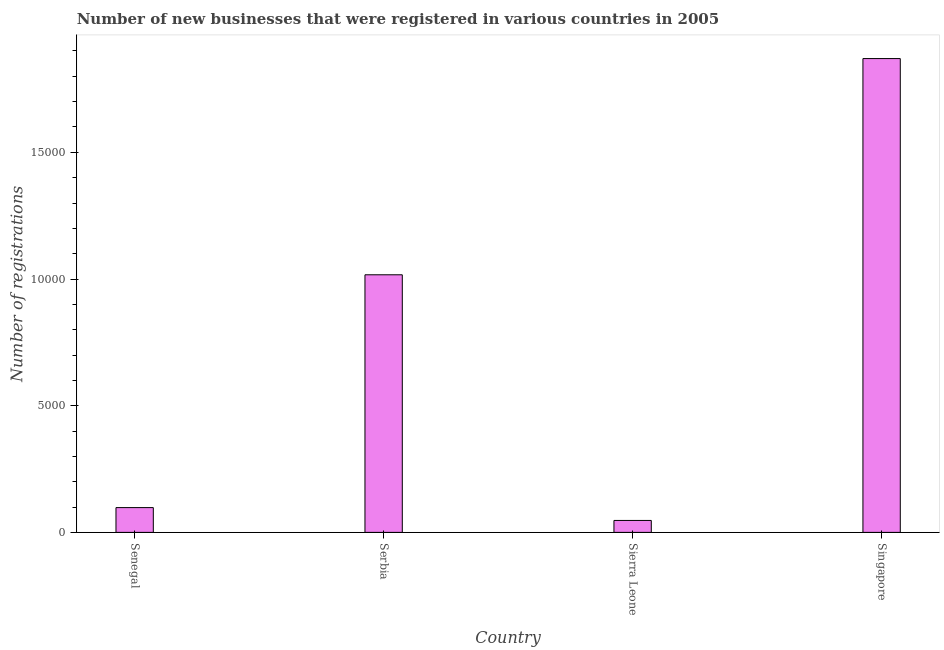Does the graph contain any zero values?
Offer a very short reply. No. Does the graph contain grids?
Make the answer very short. No. What is the title of the graph?
Provide a short and direct response. Number of new businesses that were registered in various countries in 2005. What is the label or title of the Y-axis?
Your answer should be compact. Number of registrations. What is the number of new business registrations in Serbia?
Offer a very short reply. 1.02e+04. Across all countries, what is the maximum number of new business registrations?
Provide a succinct answer. 1.87e+04. Across all countries, what is the minimum number of new business registrations?
Offer a terse response. 471. In which country was the number of new business registrations maximum?
Make the answer very short. Singapore. In which country was the number of new business registrations minimum?
Your answer should be very brief. Sierra Leone. What is the sum of the number of new business registrations?
Offer a very short reply. 3.03e+04. What is the difference between the number of new business registrations in Serbia and Singapore?
Offer a very short reply. -8534. What is the average number of new business registrations per country?
Ensure brevity in your answer.  7579. What is the median number of new business registrations?
Offer a very short reply. 5572.5. What is the ratio of the number of new business registrations in Sierra Leone to that in Singapore?
Keep it short and to the point. 0.03. What is the difference between the highest and the second highest number of new business registrations?
Keep it short and to the point. 8534. What is the difference between the highest and the lowest number of new business registrations?
Your answer should be compact. 1.82e+04. In how many countries, is the number of new business registrations greater than the average number of new business registrations taken over all countries?
Provide a succinct answer. 2. How many bars are there?
Offer a very short reply. 4. How many countries are there in the graph?
Make the answer very short. 4. Are the values on the major ticks of Y-axis written in scientific E-notation?
Your response must be concise. No. What is the Number of registrations of Senegal?
Offer a very short reply. 978. What is the Number of registrations of Serbia?
Give a very brief answer. 1.02e+04. What is the Number of registrations in Sierra Leone?
Provide a succinct answer. 471. What is the Number of registrations in Singapore?
Your answer should be compact. 1.87e+04. What is the difference between the Number of registrations in Senegal and Serbia?
Provide a succinct answer. -9189. What is the difference between the Number of registrations in Senegal and Sierra Leone?
Provide a short and direct response. 507. What is the difference between the Number of registrations in Senegal and Singapore?
Provide a succinct answer. -1.77e+04. What is the difference between the Number of registrations in Serbia and Sierra Leone?
Provide a succinct answer. 9696. What is the difference between the Number of registrations in Serbia and Singapore?
Your answer should be compact. -8534. What is the difference between the Number of registrations in Sierra Leone and Singapore?
Your response must be concise. -1.82e+04. What is the ratio of the Number of registrations in Senegal to that in Serbia?
Keep it short and to the point. 0.1. What is the ratio of the Number of registrations in Senegal to that in Sierra Leone?
Provide a succinct answer. 2.08. What is the ratio of the Number of registrations in Senegal to that in Singapore?
Your answer should be very brief. 0.05. What is the ratio of the Number of registrations in Serbia to that in Sierra Leone?
Ensure brevity in your answer.  21.59. What is the ratio of the Number of registrations in Serbia to that in Singapore?
Your response must be concise. 0.54. What is the ratio of the Number of registrations in Sierra Leone to that in Singapore?
Keep it short and to the point. 0.03. 